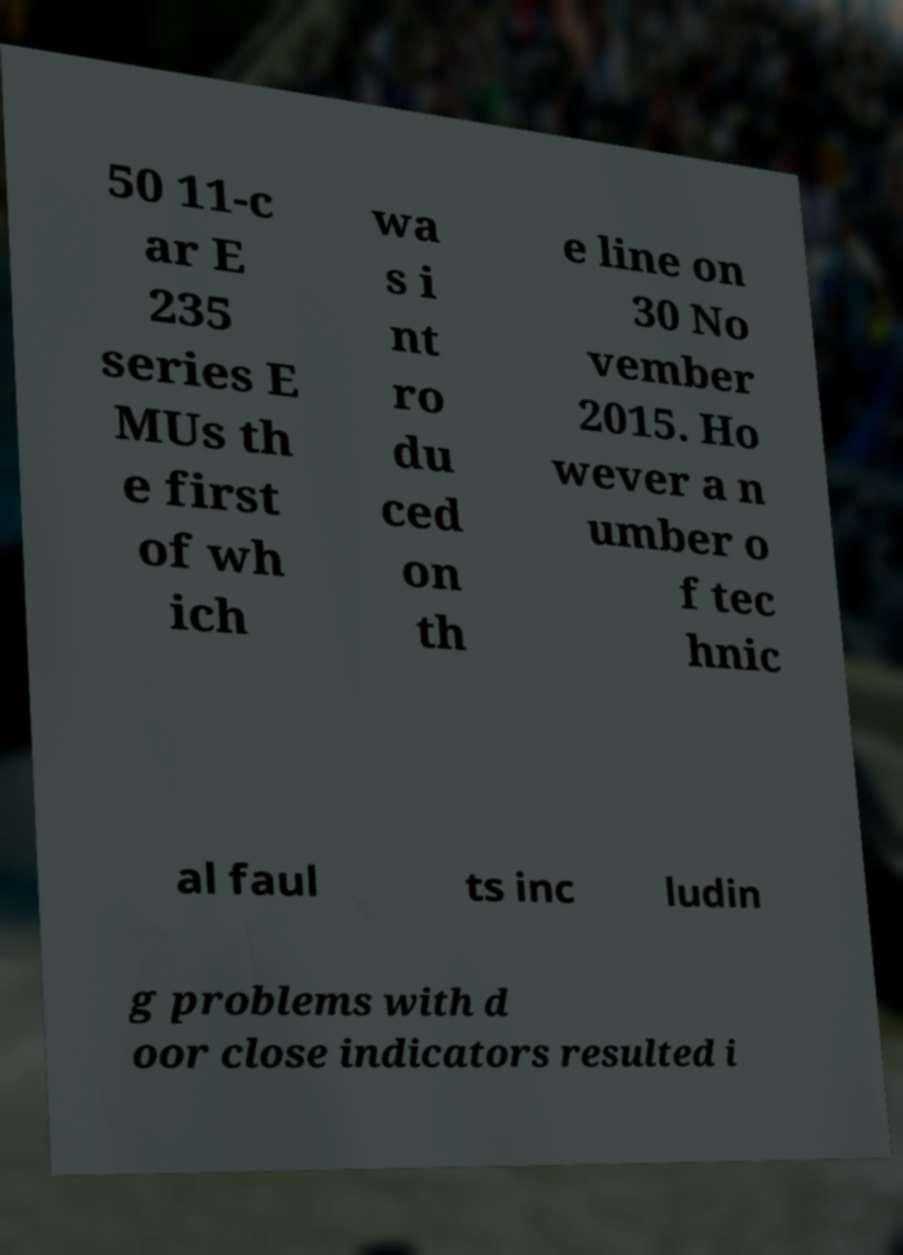Can you read and provide the text displayed in the image?This photo seems to have some interesting text. Can you extract and type it out for me? 50 11-c ar E 235 series E MUs th e first of wh ich wa s i nt ro du ced on th e line on 30 No vember 2015. Ho wever a n umber o f tec hnic al faul ts inc ludin g problems with d oor close indicators resulted i 